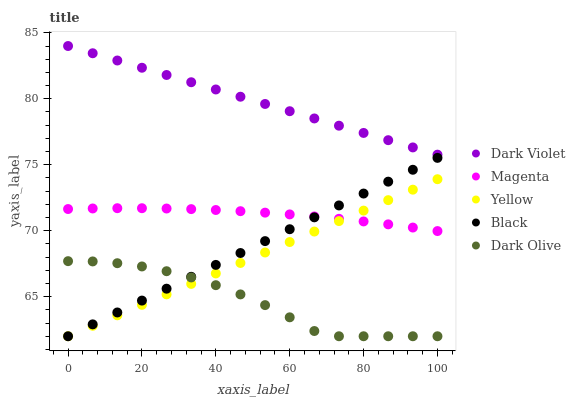Does Dark Olive have the minimum area under the curve?
Answer yes or no. Yes. Does Dark Violet have the maximum area under the curve?
Answer yes or no. Yes. Does Black have the minimum area under the curve?
Answer yes or no. No. Does Black have the maximum area under the curve?
Answer yes or no. No. Is Yellow the smoothest?
Answer yes or no. Yes. Is Dark Olive the roughest?
Answer yes or no. Yes. Is Black the smoothest?
Answer yes or no. No. Is Black the roughest?
Answer yes or no. No. Does Dark Olive have the lowest value?
Answer yes or no. Yes. Does Dark Violet have the lowest value?
Answer yes or no. No. Does Dark Violet have the highest value?
Answer yes or no. Yes. Does Black have the highest value?
Answer yes or no. No. Is Dark Olive less than Dark Violet?
Answer yes or no. Yes. Is Dark Violet greater than Magenta?
Answer yes or no. Yes. Does Magenta intersect Black?
Answer yes or no. Yes. Is Magenta less than Black?
Answer yes or no. No. Is Magenta greater than Black?
Answer yes or no. No. Does Dark Olive intersect Dark Violet?
Answer yes or no. No. 